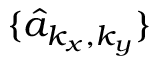Convert formula to latex. <formula><loc_0><loc_0><loc_500><loc_500>\{ \hat { a } _ { k _ { x } , k _ { y } } \}</formula> 